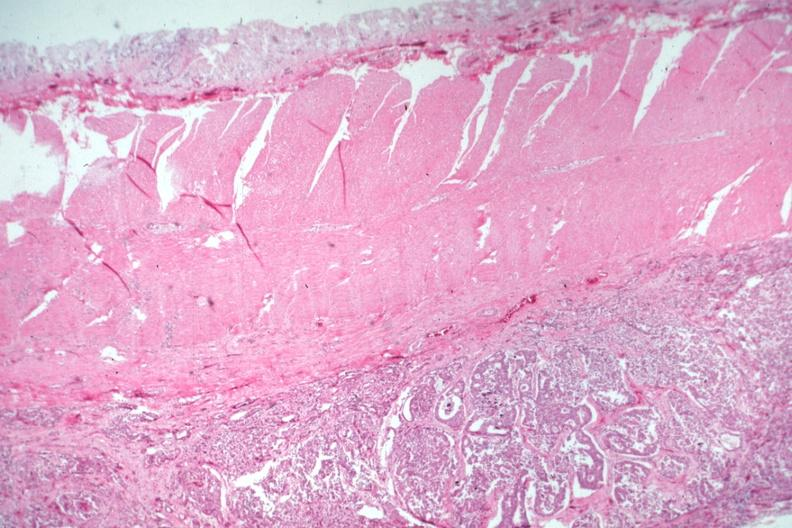what is present?
Answer the question using a single word or phrase. Gastrointestinal 